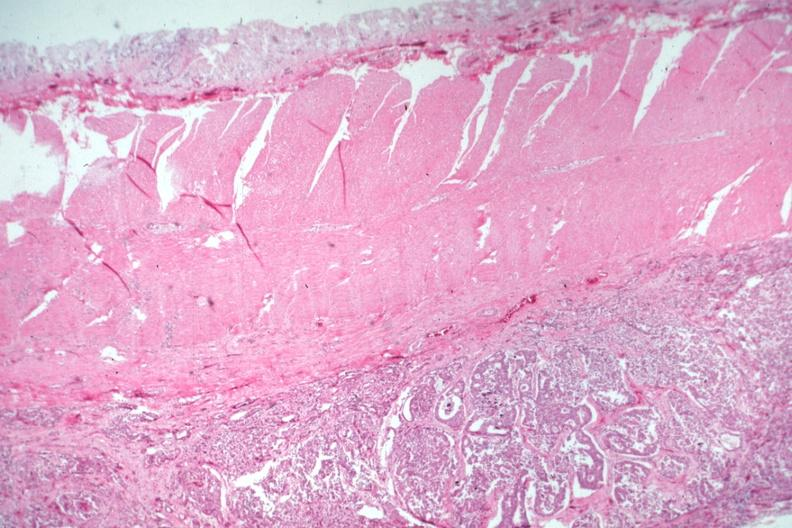what is present?
Answer the question using a single word or phrase. Gastrointestinal 